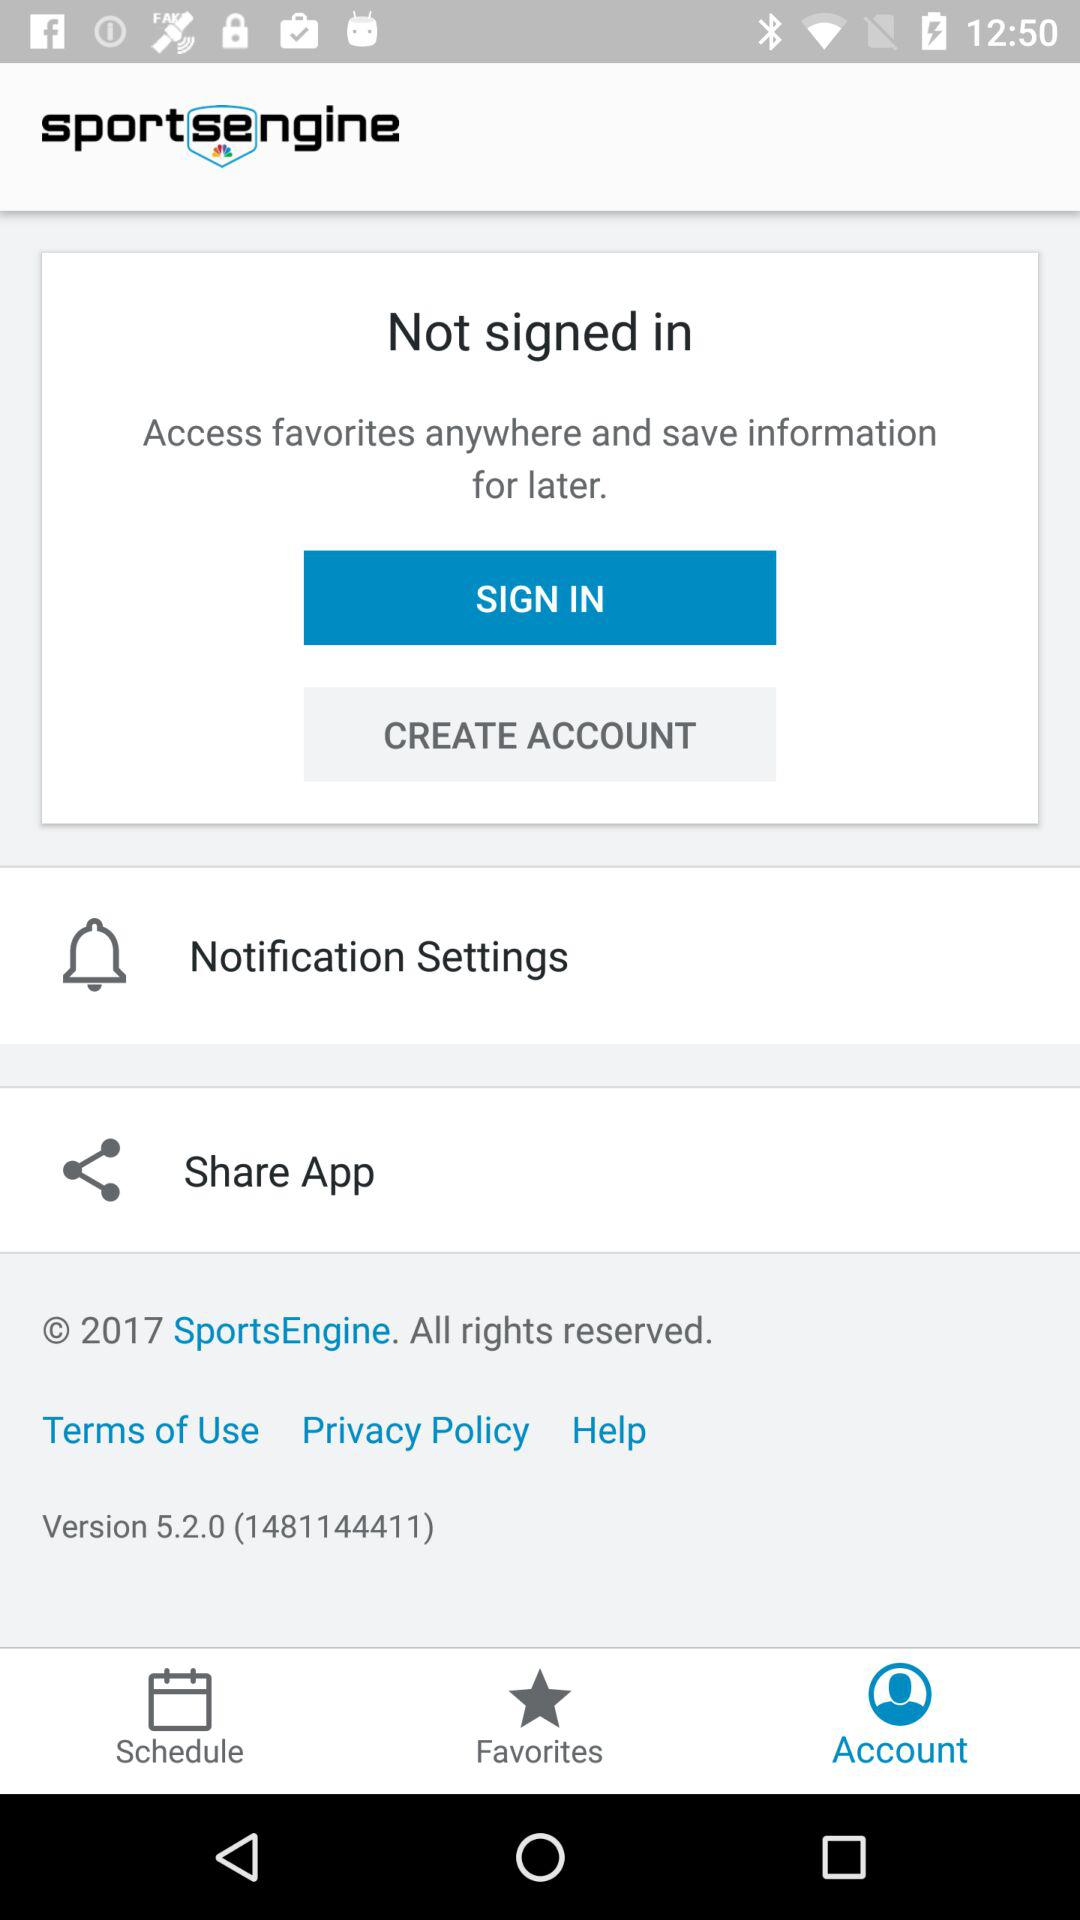Which tab is selected? The selected tab is "Account". 